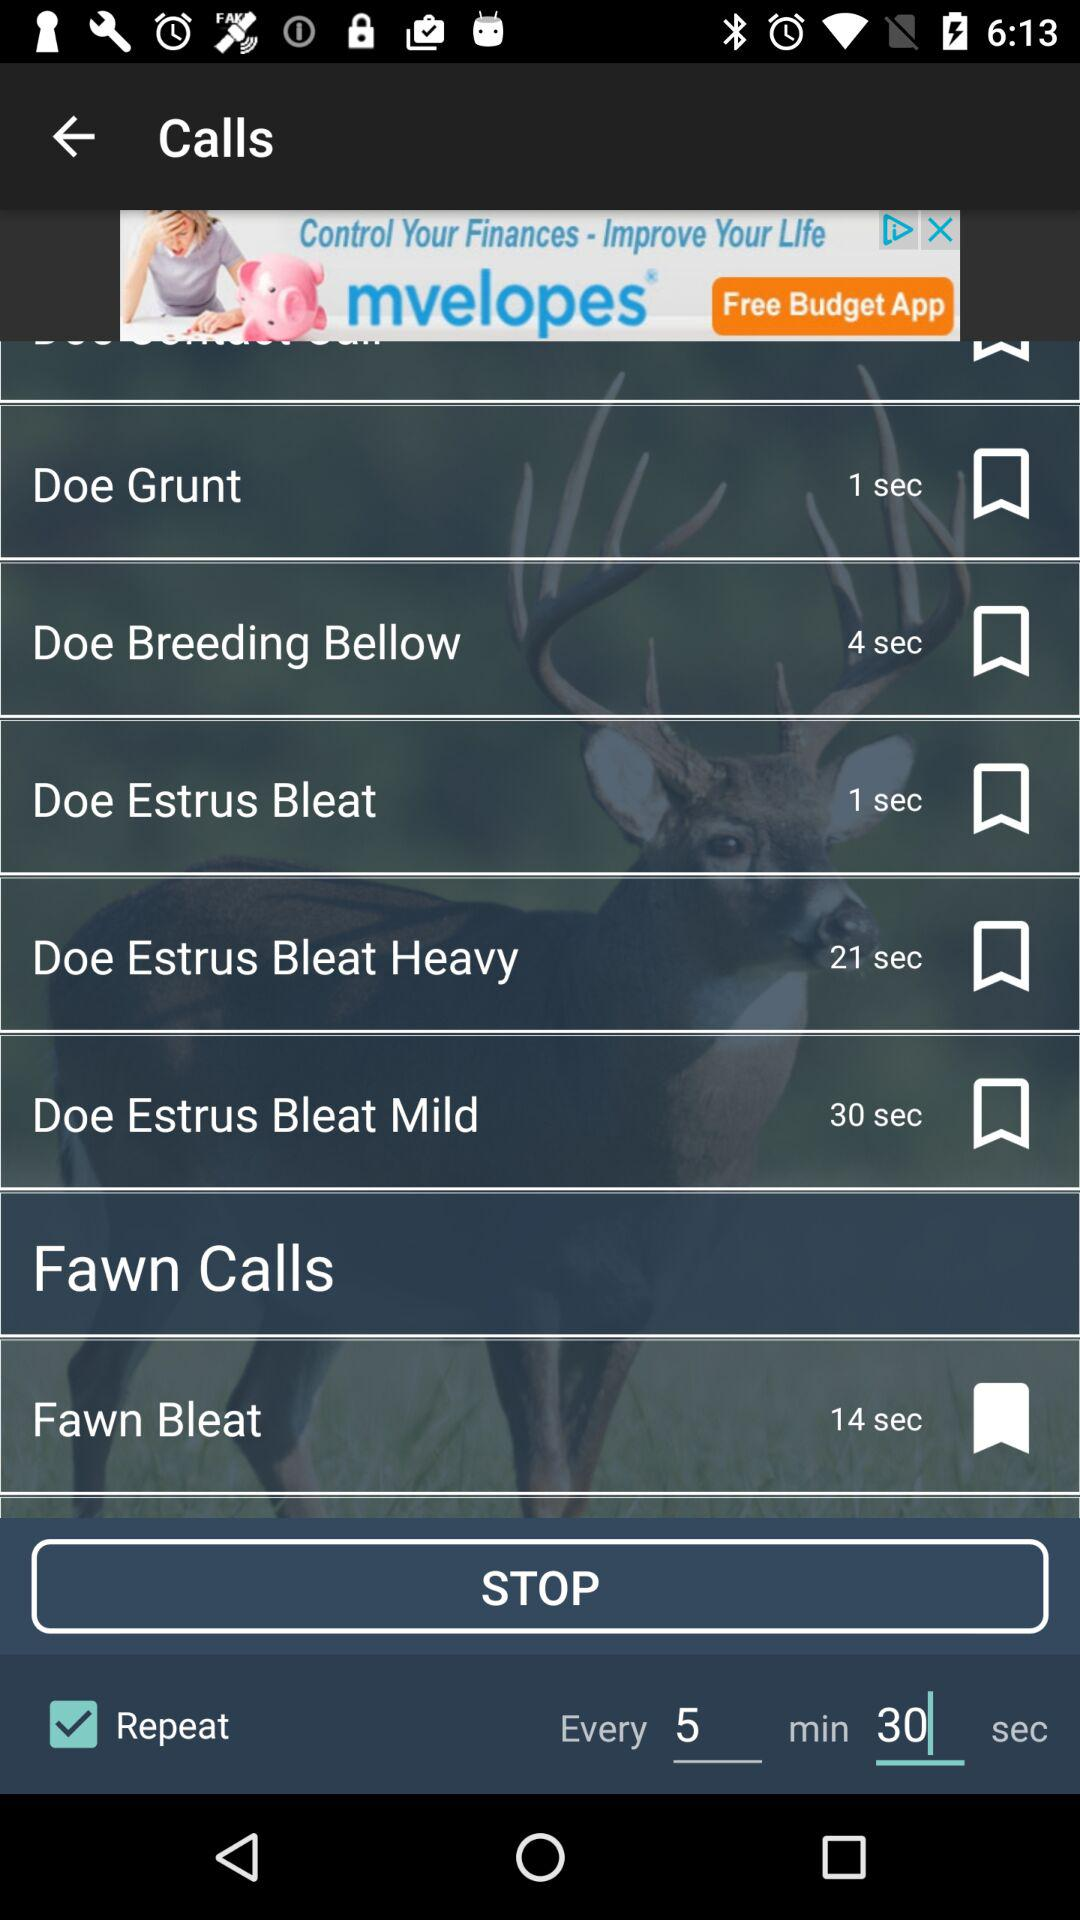What is the time duration of the call Doe Grunt? The duration of the call is 1 second. 